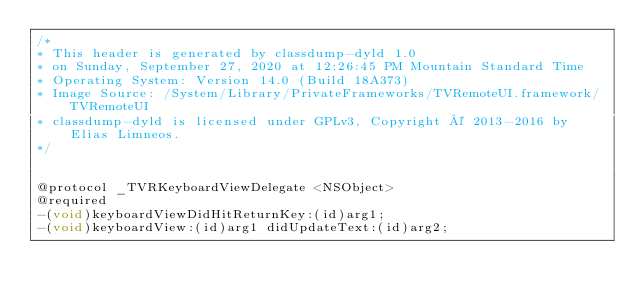Convert code to text. <code><loc_0><loc_0><loc_500><loc_500><_C_>/*
* This header is generated by classdump-dyld 1.0
* on Sunday, September 27, 2020 at 12:26:45 PM Mountain Standard Time
* Operating System: Version 14.0 (Build 18A373)
* Image Source: /System/Library/PrivateFrameworks/TVRemoteUI.framework/TVRemoteUI
* classdump-dyld is licensed under GPLv3, Copyright © 2013-2016 by Elias Limneos.
*/


@protocol _TVRKeyboardViewDelegate <NSObject>
@required
-(void)keyboardViewDidHitReturnKey:(id)arg1;
-(void)keyboardView:(id)arg1 didUpdateText:(id)arg2;</code> 